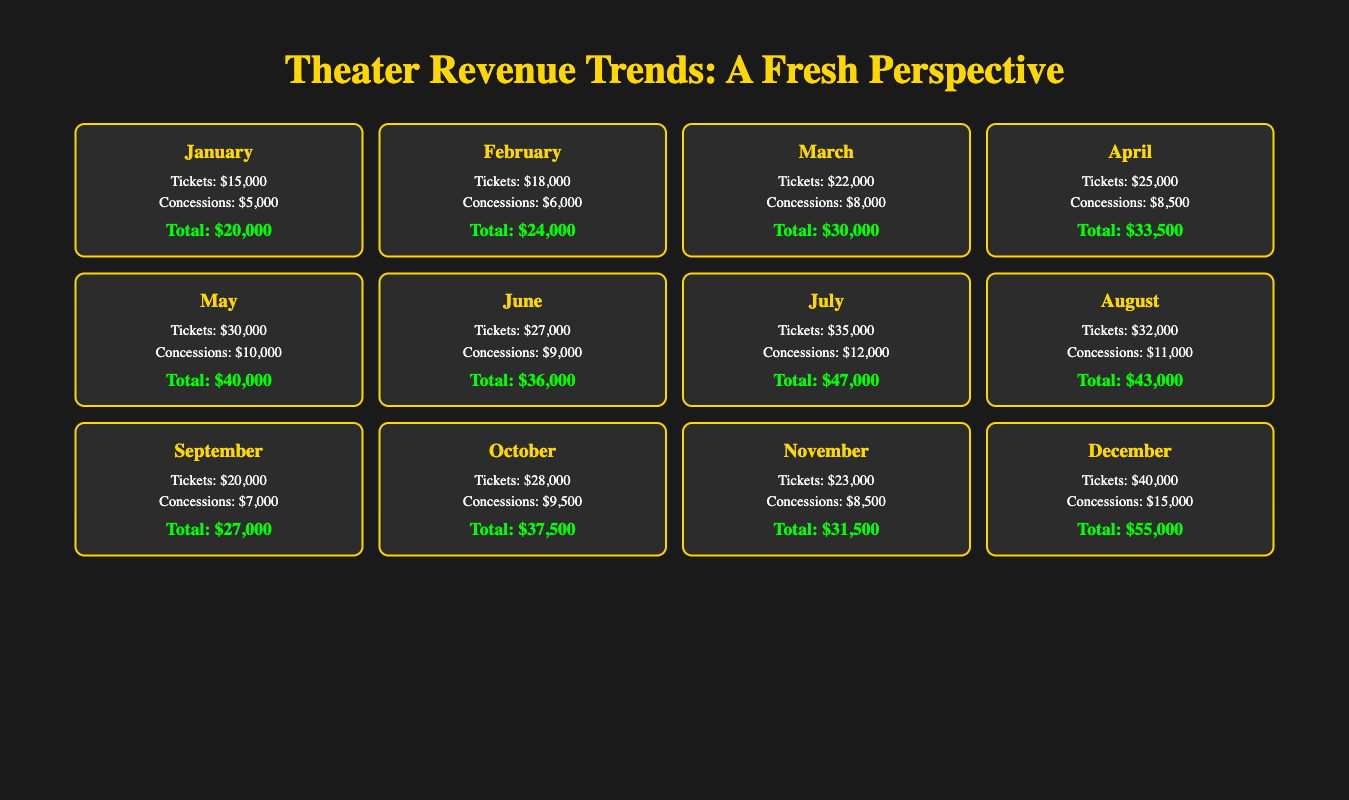What was the total revenue in December? In December, the total revenue is listed in the table as $55,000.
Answer: 55,000 What were the ticket sales in July? The table shows that ticket sales in July amounted to $35,000.
Answer: 35,000 Which month had the highest total revenue, and what was that amount? The month with the highest total revenue is December with $55,000.
Answer: December, 55,000 What is the average ticket sales from January to June? To find the average, first sum the ticket sales from January ($15,000), February ($18,000), March ($22,000), April ($25,000), May ($30,000), and June ($27,000). The total is $15,000 + $18,000 + $22,000 + $25,000 + $30,000 + $27,000 = $137,000. There are 6 months, so the average is $137,000 / 6 = approximately $22,833.
Answer: 22,833 Did ticket sales in August exceed those in June? August had ticket sales of $32,000 and June had $27,000. Since $32,000 is greater than $27,000, the statement is true.
Answer: Yes What was the total revenue for the first half of the year (January to June)? Sum the total revenue for January ($20,000), February ($24,000), March ($30,000), April ($33,500), May ($40,000), and June ($36,000). The total is $20,000 + $24,000 + $30,000 + $33,500 + $40,000 + $36,000 = $203,500.
Answer: 203,500 What was the percentage increase in total revenue from November to December? Total revenue in November is $31,500 and in December is $55,000. The increase is $55,000 - $31,500 = $23,500. To find the percentage increase: ($23,500 / $31,500) * 100 ≈ 74.60%.
Answer: 74.60% Which month had the lowest ticket sales, and what were the sales figures? The lowest ticket sales were in January with $15,000.
Answer: January, 15,000 